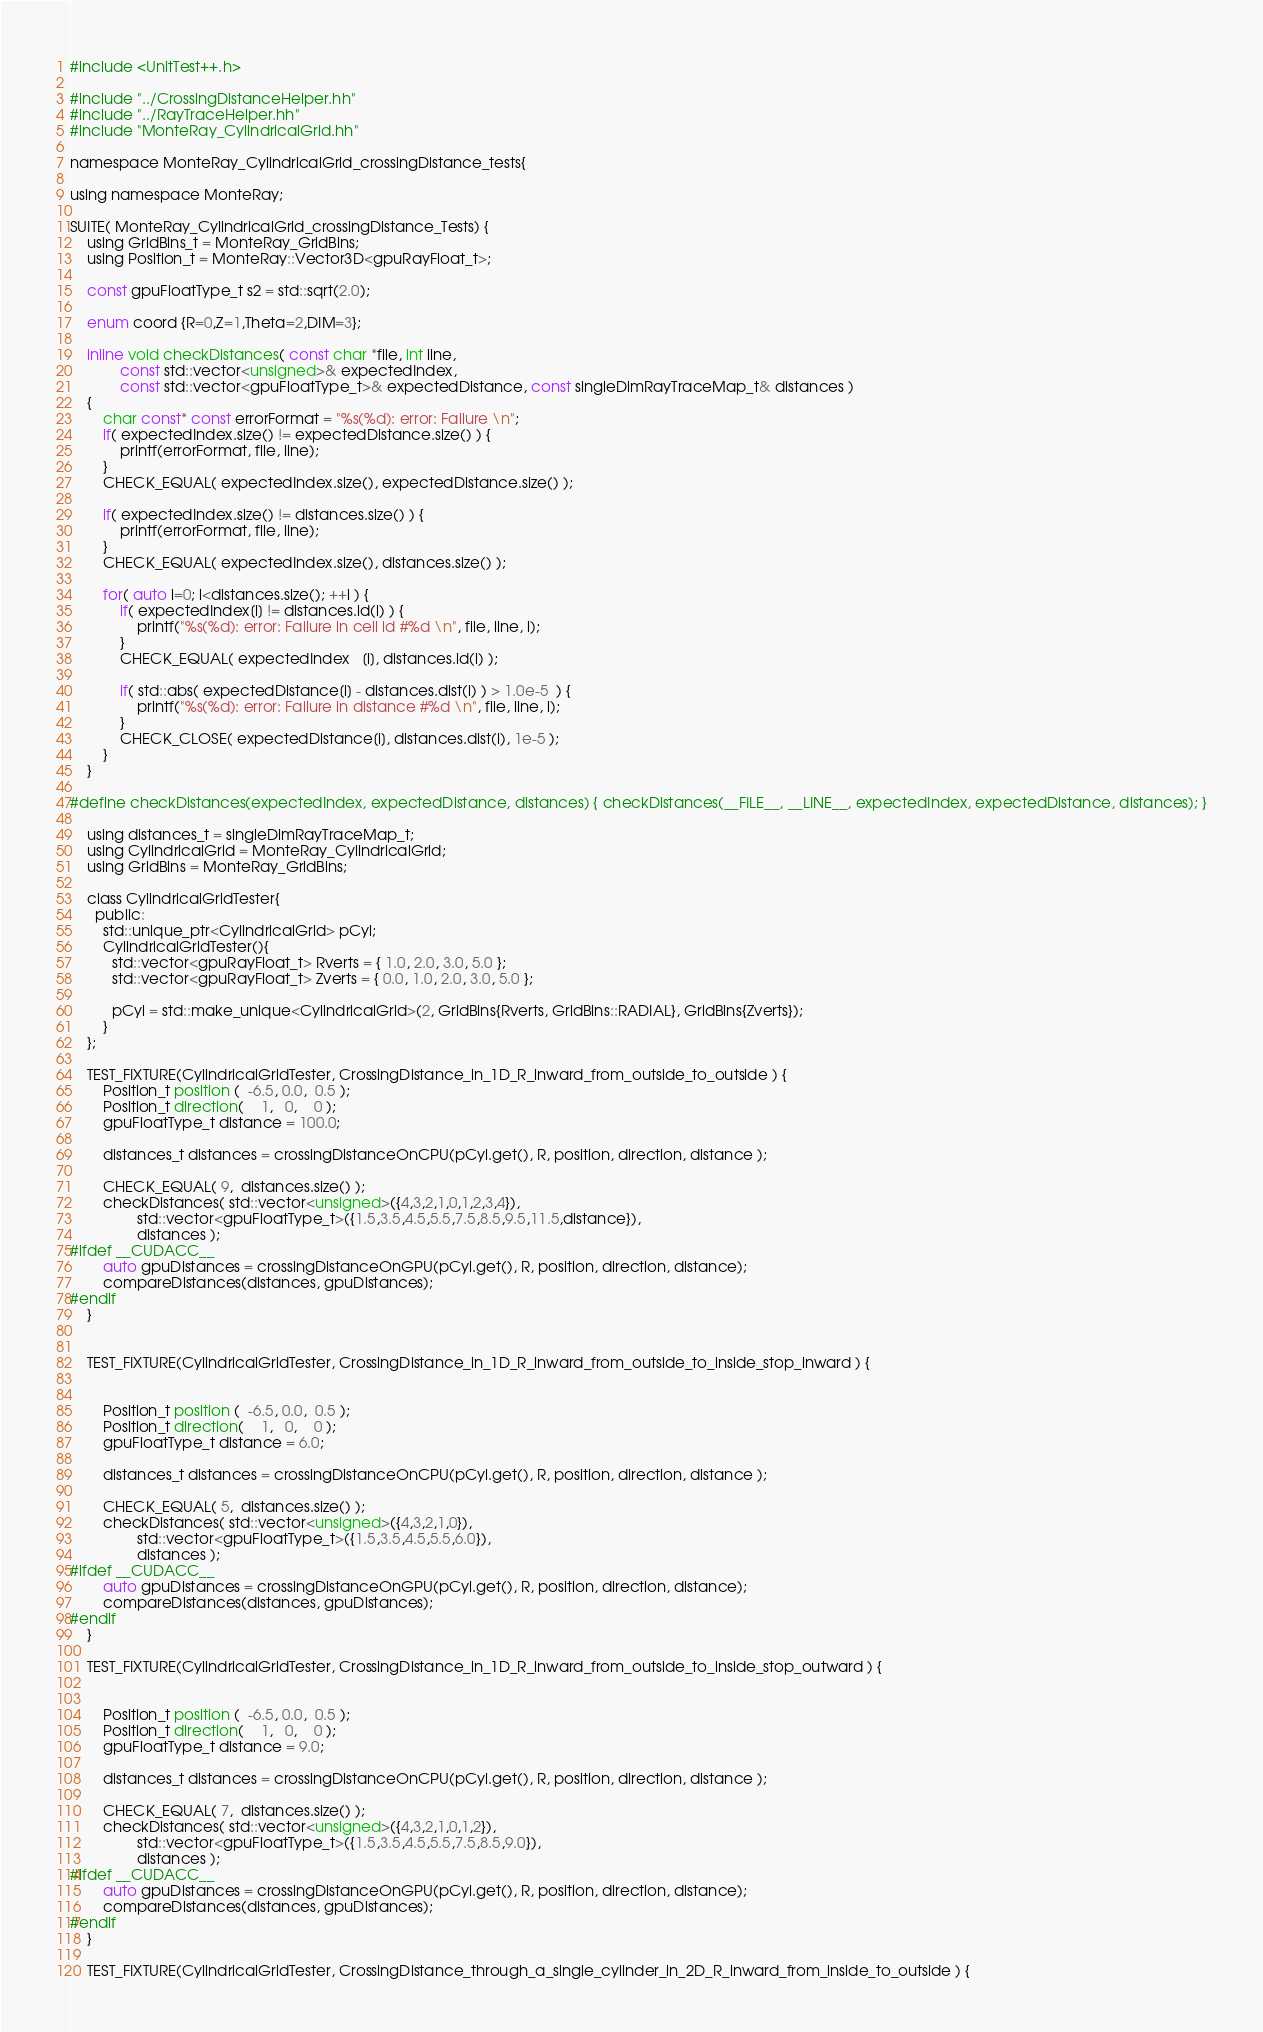Convert code to text. <code><loc_0><loc_0><loc_500><loc_500><_Cuda_>#include <UnitTest++.h>

#include "../CrossingDistanceHelper.hh"
#include "../RayTraceHelper.hh"
#include "MonteRay_CylindricalGrid.hh"

namespace MonteRay_CylindricalGrid_crossingDistance_tests{

using namespace MonteRay;

SUITE( MonteRay_CylindricalGrid_crossingDistance_Tests) {
    using GridBins_t = MonteRay_GridBins;
    using Position_t = MonteRay::Vector3D<gpuRayFloat_t>;

    const gpuFloatType_t s2 = std::sqrt(2.0);

    enum coord {R=0,Z=1,Theta=2,DIM=3};

    inline void checkDistances( const char *file, int line,
            const std::vector<unsigned>& expectedIndex,
            const std::vector<gpuFloatType_t>& expectedDistance, const singleDimRayTraceMap_t& distances )
    {
        char const* const errorFormat = "%s(%d): error: Failure \n";
        if( expectedIndex.size() != expectedDistance.size() ) {
            printf(errorFormat, file, line);
        }
        CHECK_EQUAL( expectedIndex.size(), expectedDistance.size() );

        if( expectedIndex.size() != distances.size() ) {
            printf(errorFormat, file, line);
        }
        CHECK_EQUAL( expectedIndex.size(), distances.size() );

        for( auto i=0; i<distances.size(); ++i ) {
            if( expectedIndex[i] != distances.id(i) ) {
                printf("%s(%d): error: Failure in cell id #%d \n", file, line, i);
            }
            CHECK_EQUAL( expectedIndex   [i], distances.id(i) );

            if( std::abs( expectedDistance[i] - distances.dist(i) ) > 1.0e-5  ) {
                printf("%s(%d): error: Failure in distance #%d \n", file, line, i);
            }
            CHECK_CLOSE( expectedDistance[i], distances.dist(i), 1e-5 );
        }
    }

#define checkDistances(expectedIndex, expectedDistance, distances) { checkDistances(__FILE__, __LINE__, expectedIndex, expectedDistance, distances); }

    using distances_t = singleDimRayTraceMap_t;
    using CylindricalGrid = MonteRay_CylindricalGrid;
    using GridBins = MonteRay_GridBins;

    class CylindricalGridTester{
      public:
        std::unique_ptr<CylindricalGrid> pCyl;
        CylindricalGridTester(){
          std::vector<gpuRayFloat_t> Rverts = { 1.0, 2.0, 3.0, 5.0 };
          std::vector<gpuRayFloat_t> Zverts = { 0.0, 1.0, 2.0, 3.0, 5.0 };
        
          pCyl = std::make_unique<CylindricalGrid>(2, GridBins{Rverts, GridBins::RADIAL}, GridBins{Zverts});
        }
    };

    TEST_FIXTURE(CylindricalGridTester, CrossingDistance_in_1D_R_inward_from_outside_to_outside ) {
        Position_t position (  -6.5, 0.0,  0.5 );
        Position_t direction(    1,   0,    0 );
        gpuFloatType_t distance = 100.0;

        distances_t distances = crossingDistanceOnCPU(pCyl.get(), R, position, direction, distance );

        CHECK_EQUAL( 9,  distances.size() );
        checkDistances( std::vector<unsigned>({4,3,2,1,0,1,2,3,4}),
                std::vector<gpuFloatType_t>({1.5,3.5,4.5,5.5,7.5,8.5,9.5,11.5,distance}),
                distances );
#ifdef __CUDACC__
        auto gpuDistances = crossingDistanceOnGPU(pCyl.get(), R, position, direction, distance);
        compareDistances(distances, gpuDistances);
#endif
    }


    TEST_FIXTURE(CylindricalGridTester, CrossingDistance_in_1D_R_inward_from_outside_to_inside_stop_inward ) {


        Position_t position (  -6.5, 0.0,  0.5 );
        Position_t direction(    1,   0,    0 );
        gpuFloatType_t distance = 6.0;

        distances_t distances = crossingDistanceOnCPU(pCyl.get(), R, position, direction, distance );

        CHECK_EQUAL( 5,  distances.size() );
        checkDistances( std::vector<unsigned>({4,3,2,1,0}),
                std::vector<gpuFloatType_t>({1.5,3.5,4.5,5.5,6.0}),
                distances );
#ifdef __CUDACC__
        auto gpuDistances = crossingDistanceOnGPU(pCyl.get(), R, position, direction, distance);
        compareDistances(distances, gpuDistances);
#endif
    }

    TEST_FIXTURE(CylindricalGridTester, CrossingDistance_in_1D_R_inward_from_outside_to_inside_stop_outward ) {


        Position_t position (  -6.5, 0.0,  0.5 );
        Position_t direction(    1,   0,    0 );
        gpuFloatType_t distance = 9.0;

        distances_t distances = crossingDistanceOnCPU(pCyl.get(), R, position, direction, distance );

        CHECK_EQUAL( 7,  distances.size() );
        checkDistances( std::vector<unsigned>({4,3,2,1,0,1,2}),
                std::vector<gpuFloatType_t>({1.5,3.5,4.5,5.5,7.5,8.5,9.0}),
                distances );
#ifdef __CUDACC__
        auto gpuDistances = crossingDistanceOnGPU(pCyl.get(), R, position, direction, distance);
        compareDistances(distances, gpuDistances);
#endif
    }

    TEST_FIXTURE(CylindricalGridTester, CrossingDistance_through_a_single_cylinder_in_2D_R_inward_from_inside_to_outside ) {

</code> 